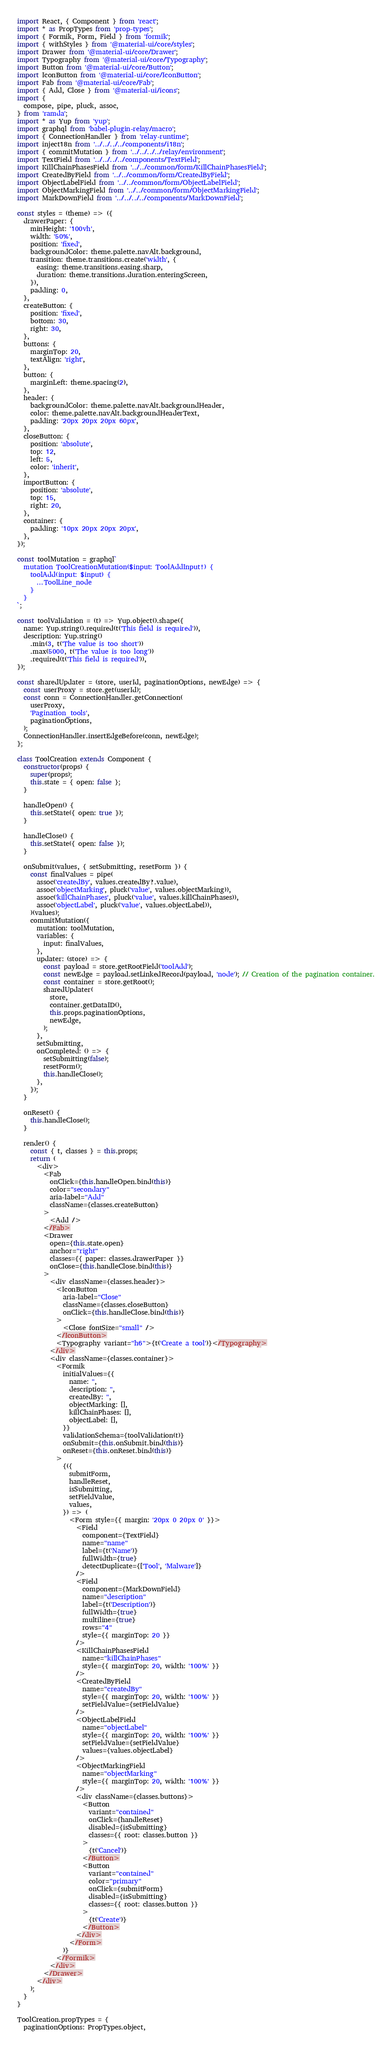Convert code to text. <code><loc_0><loc_0><loc_500><loc_500><_JavaScript_>import React, { Component } from 'react';
import * as PropTypes from 'prop-types';
import { Formik, Form, Field } from 'formik';
import { withStyles } from '@material-ui/core/styles';
import Drawer from '@material-ui/core/Drawer';
import Typography from '@material-ui/core/Typography';
import Button from '@material-ui/core/Button';
import IconButton from '@material-ui/core/IconButton';
import Fab from '@material-ui/core/Fab';
import { Add, Close } from '@material-ui/icons';
import {
  compose, pipe, pluck, assoc,
} from 'ramda';
import * as Yup from 'yup';
import graphql from 'babel-plugin-relay/macro';
import { ConnectionHandler } from 'relay-runtime';
import inject18n from '../../../../components/i18n';
import { commitMutation } from '../../../../relay/environment';
import TextField from '../../../../components/TextField';
import KillChainPhasesField from '../../common/form/KillChainPhasesField';
import CreatedByField from '../../common/form/CreatedByField';
import ObjectLabelField from '../../common/form/ObjectLabelField';
import ObjectMarkingField from '../../common/form/ObjectMarkingField';
import MarkDownField from '../../../../components/MarkDownField';

const styles = (theme) => ({
  drawerPaper: {
    minHeight: '100vh',
    width: '50%',
    position: 'fixed',
    backgroundColor: theme.palette.navAlt.background,
    transition: theme.transitions.create('width', {
      easing: theme.transitions.easing.sharp,
      duration: theme.transitions.duration.enteringScreen,
    }),
    padding: 0,
  },
  createButton: {
    position: 'fixed',
    bottom: 30,
    right: 30,
  },
  buttons: {
    marginTop: 20,
    textAlign: 'right',
  },
  button: {
    marginLeft: theme.spacing(2),
  },
  header: {
    backgroundColor: theme.palette.navAlt.backgroundHeader,
    color: theme.palette.navAlt.backgroundHeaderText,
    padding: '20px 20px 20px 60px',
  },
  closeButton: {
    position: 'absolute',
    top: 12,
    left: 5,
    color: 'inherit',
  },
  importButton: {
    position: 'absolute',
    top: 15,
    right: 20,
  },
  container: {
    padding: '10px 20px 20px 20px',
  },
});

const toolMutation = graphql`
  mutation ToolCreationMutation($input: ToolAddInput!) {
    toolAdd(input: $input) {
      ...ToolLine_node
    }
  }
`;

const toolValidation = (t) => Yup.object().shape({
  name: Yup.string().required(t('This field is required')),
  description: Yup.string()
    .min(3, t('The value is too short'))
    .max(5000, t('The value is too long'))
    .required(t('This field is required')),
});

const sharedUpdater = (store, userId, paginationOptions, newEdge) => {
  const userProxy = store.get(userId);
  const conn = ConnectionHandler.getConnection(
    userProxy,
    'Pagination_tools',
    paginationOptions,
  );
  ConnectionHandler.insertEdgeBefore(conn, newEdge);
};

class ToolCreation extends Component {
  constructor(props) {
    super(props);
    this.state = { open: false };
  }

  handleOpen() {
    this.setState({ open: true });
  }

  handleClose() {
    this.setState({ open: false });
  }

  onSubmit(values, { setSubmitting, resetForm }) {
    const finalValues = pipe(
      assoc('createdBy', values.createdBy?.value),
      assoc('objectMarking', pluck('value', values.objectMarking)),
      assoc('killChainPhases', pluck('value', values.killChainPhases)),
      assoc('objectLabel', pluck('value', values.objectLabel)),
    )(values);
    commitMutation({
      mutation: toolMutation,
      variables: {
        input: finalValues,
      },
      updater: (store) => {
        const payload = store.getRootField('toolAdd');
        const newEdge = payload.setLinkedRecord(payload, 'node'); // Creation of the pagination container.
        const container = store.getRoot();
        sharedUpdater(
          store,
          container.getDataID(),
          this.props.paginationOptions,
          newEdge,
        );
      },
      setSubmitting,
      onCompleted: () => {
        setSubmitting(false);
        resetForm();
        this.handleClose();
      },
    });
  }

  onReset() {
    this.handleClose();
  }

  render() {
    const { t, classes } = this.props;
    return (
      <div>
        <Fab
          onClick={this.handleOpen.bind(this)}
          color="secondary"
          aria-label="Add"
          className={classes.createButton}
        >
          <Add />
        </Fab>
        <Drawer
          open={this.state.open}
          anchor="right"
          classes={{ paper: classes.drawerPaper }}
          onClose={this.handleClose.bind(this)}
        >
          <div className={classes.header}>
            <IconButton
              aria-label="Close"
              className={classes.closeButton}
              onClick={this.handleClose.bind(this)}
            >
              <Close fontSize="small" />
            </IconButton>
            <Typography variant="h6">{t('Create a tool')}</Typography>
          </div>
          <div className={classes.container}>
            <Formik
              initialValues={{
                name: '',
                description: '',
                createdBy: '',
                objectMarking: [],
                killChainPhases: [],
                objectLabel: [],
              }}
              validationSchema={toolValidation(t)}
              onSubmit={this.onSubmit.bind(this)}
              onReset={this.onReset.bind(this)}
            >
              {({
                submitForm,
                handleReset,
                isSubmitting,
                setFieldValue,
                values,
              }) => (
                <Form style={{ margin: '20px 0 20px 0' }}>
                  <Field
                    component={TextField}
                    name="name"
                    label={t('Name')}
                    fullWidth={true}
                    detectDuplicate={['Tool', 'Malware']}
                  />
                  <Field
                    component={MarkDownField}
                    name="description"
                    label={t('Description')}
                    fullWidth={true}
                    multiline={true}
                    rows="4"
                    style={{ marginTop: 20 }}
                  />
                  <KillChainPhasesField
                    name="killChainPhases"
                    style={{ marginTop: 20, width: '100%' }}
                  />
                  <CreatedByField
                    name="createdBy"
                    style={{ marginTop: 20, width: '100%' }}
                    setFieldValue={setFieldValue}
                  />
                  <ObjectLabelField
                    name="objectLabel"
                    style={{ marginTop: 20, width: '100%' }}
                    setFieldValue={setFieldValue}
                    values={values.objectLabel}
                  />
                  <ObjectMarkingField
                    name="objectMarking"
                    style={{ marginTop: 20, width: '100%' }}
                  />
                  <div className={classes.buttons}>
                    <Button
                      variant="contained"
                      onClick={handleReset}
                      disabled={isSubmitting}
                      classes={{ root: classes.button }}
                    >
                      {t('Cancel')}
                    </Button>
                    <Button
                      variant="contained"
                      color="primary"
                      onClick={submitForm}
                      disabled={isSubmitting}
                      classes={{ root: classes.button }}
                    >
                      {t('Create')}
                    </Button>
                  </div>
                </Form>
              )}
            </Formik>
          </div>
        </Drawer>
      </div>
    );
  }
}

ToolCreation.propTypes = {
  paginationOptions: PropTypes.object,</code> 